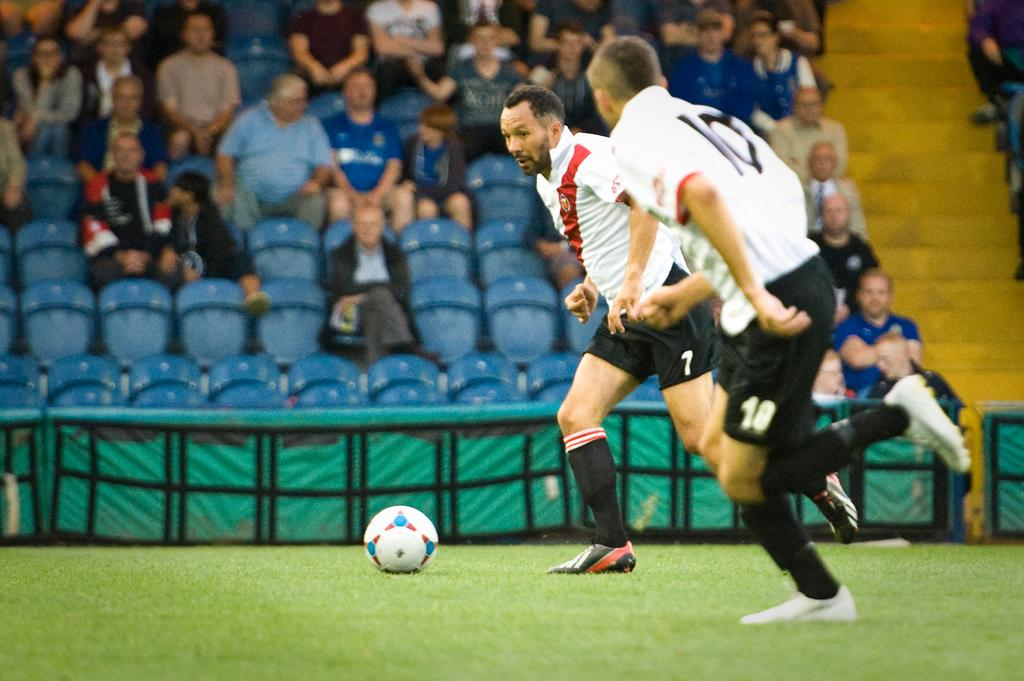How many people are in the image? There are two persons in the image. What are the persons wearing? Both persons are wearing white t-shirts and black shorts. Where are the persons standing? The persons are standing on the ground. What can be seen in the background of the image? There is a group of audience in the background of the image. What type of scissors are the persons using to cut the vessel in the image? There are no scissors or vessels present in the image. What message are the persons conveying as they say good-bye in the image? There is no indication of a good-bye or any message being conveyed in the image. 